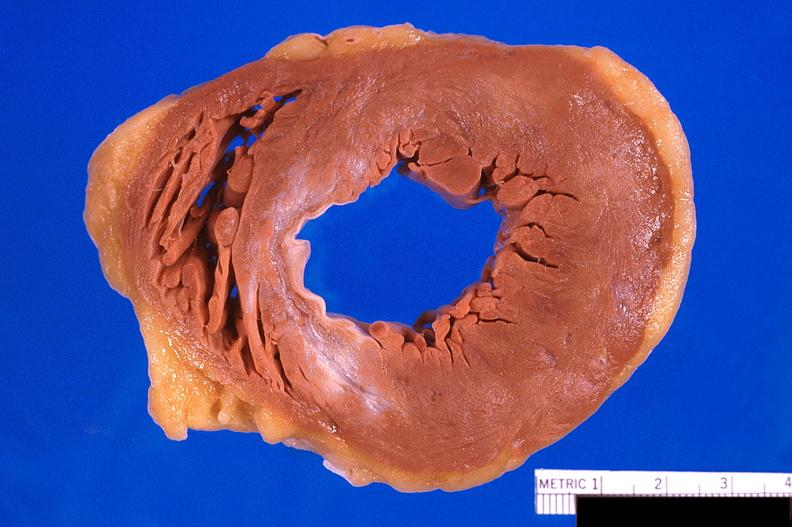what is present?
Answer the question using a single word or phrase. Cardiovascular 